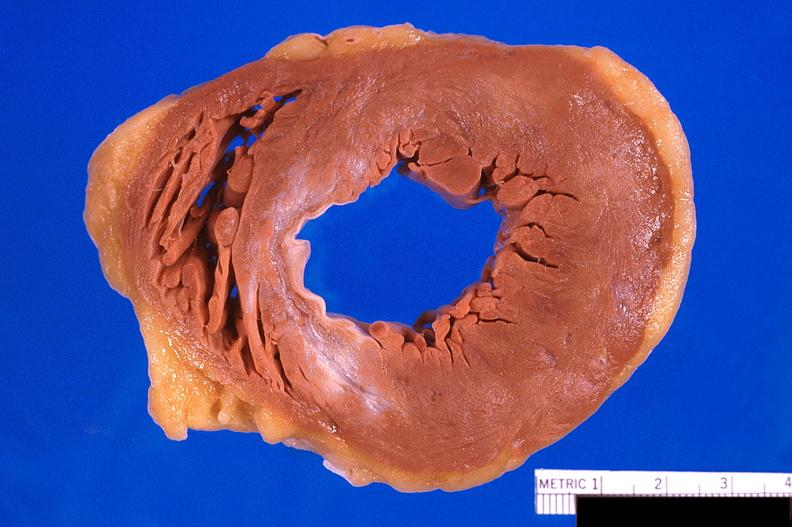what is present?
Answer the question using a single word or phrase. Cardiovascular 